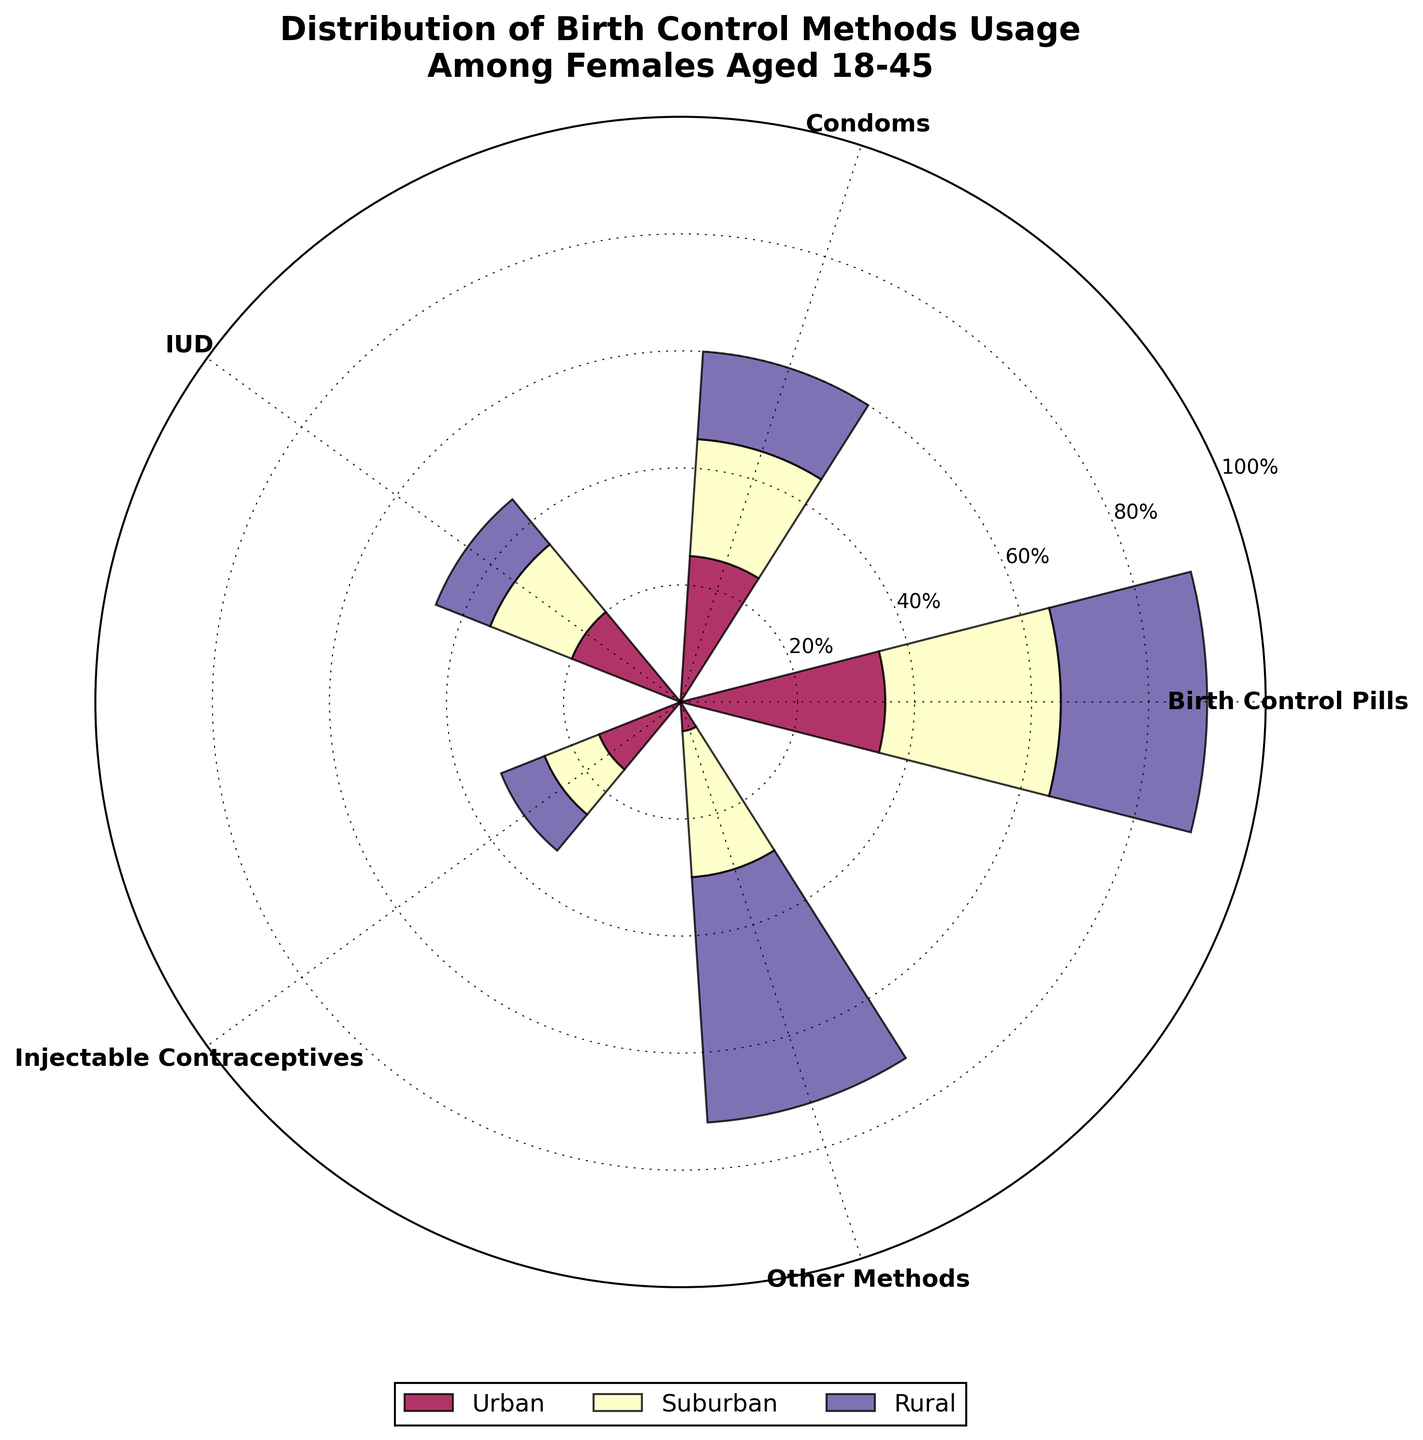What percentage of females in rural areas use injectable contraceptives? Look at the section labeled "Injectable Contraceptives" and check the segment corresponding to the rural areas. This plot section shows 8%.
Answer: 8% How does the usage of birth control pills compare between urban and suburban areas? Compare the two segments for "Birth Control Pills" under urban and suburban categories. Urban is 35% while suburban is 30%, so urban usage is higher.
Answer: Urban is higher Which method has the highest usage in suburban areas? Look at the different methods for the suburban category and find the highest value. "Other Methods" stands out with 25%.
Answer: Other Methods What is the sum of percentages for condoms across all areas? Add the percentages from urban (25%), suburban (20%), and rural (15%) for condoms. 25% + 20% + 15% = 60%.
Answer: 60% What is the average percentage of IUD usage across urban, suburban, and rural areas? Calculate the average by adding the IUD percentages for urban (20%), suburban (15%), and rural (10%) and then divide by 3. The sum is 45%, and the average is 45% / 3 = 15%.
Answer: 15% Which area has the least percentage use of birth control pills? Compare the "Birth Control Pills" percentages among urban (35%), suburban (30%), and rural (25%) areas. Rural has the lowest at 25%.
Answer: Rural What is the combined percentage of other methods in urban and suburban areas? Add the percentages for "Other Methods" from the urban (5%) and suburban (25%) areas. 5% + 25% = 30%.
Answer: 30% How much lower is the percentage of IUDs used in rural areas compared to urban areas? Subtract the rural percentage for IUDs (10%) from the urban percentage (20%). 20% - 10% = 10%.
Answer: 10% Which method shows the most significant variation across all three areas? Compare the range of percentages for each method. "Other Methods" ranges from 5% in urban to 42% in rural areas, indicating the most variation.
Answer: Other Methods What is the rank order of birth control methods in urban areas from highest to lowest usage? Rank urban percentages: Birth Control Pills (35%), Condoms (25%), IUD (20%), Injectable Contraceptives (15%), Other Methods (5%).
Answer: Birth Control Pills, Condoms, IUD, Injectable Contraceptives, Other Methods 